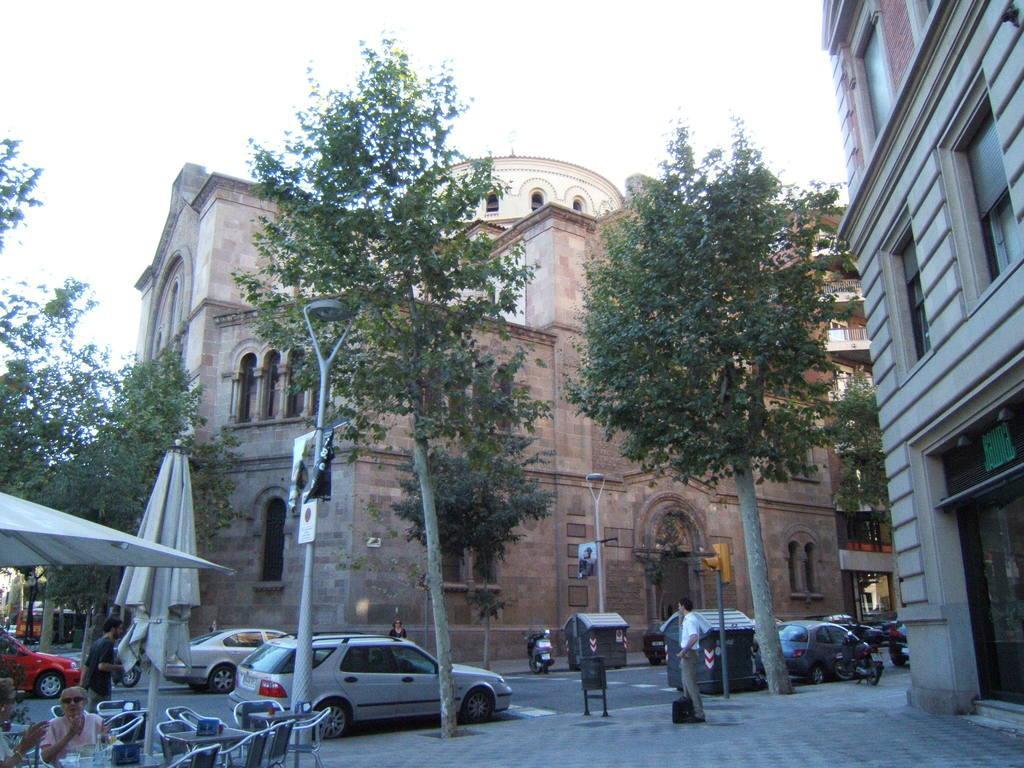Could you give a brief overview of what you see in this image? On the right there is a building. In the foreground there are chairs, canopy, umbrella, trees and footpath. In the middle of the picture there are vehicles, buildings and trees. At the top sky. In the foreground there are people also. 